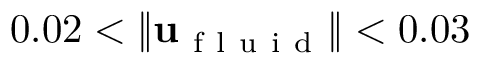<formula> <loc_0><loc_0><loc_500><loc_500>0 . 0 2 < \| u _ { f l u i d } \| < 0 . 0 3</formula> 